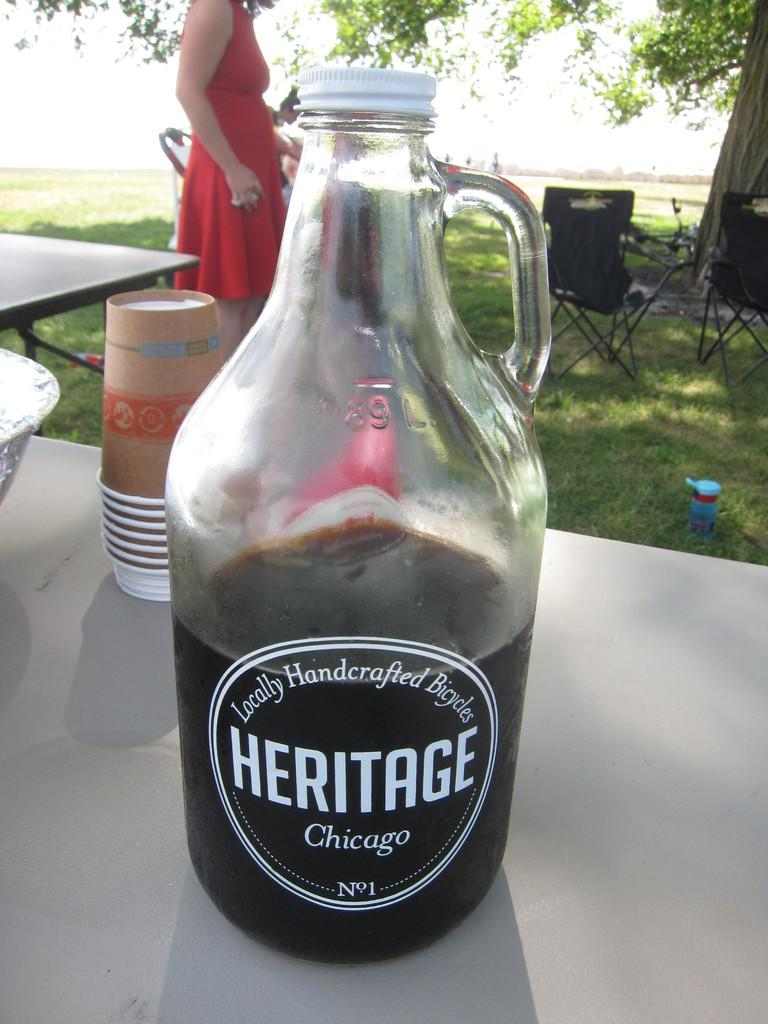What is on the table in the image? There is a bottle and cups on the table in the image. What can be seen behind the table? There is a grassland, chairs, and a tree in the background. What is the lady wearing in the image? The lady is wearing a red dress in the image. What type of brake can be seen on the lady's dress in the image? There is no brake present on the lady's dress in the image. How does the lady's body change throughout the image? The lady's body does not change throughout the image; she is wearing a red dress and standing still. 